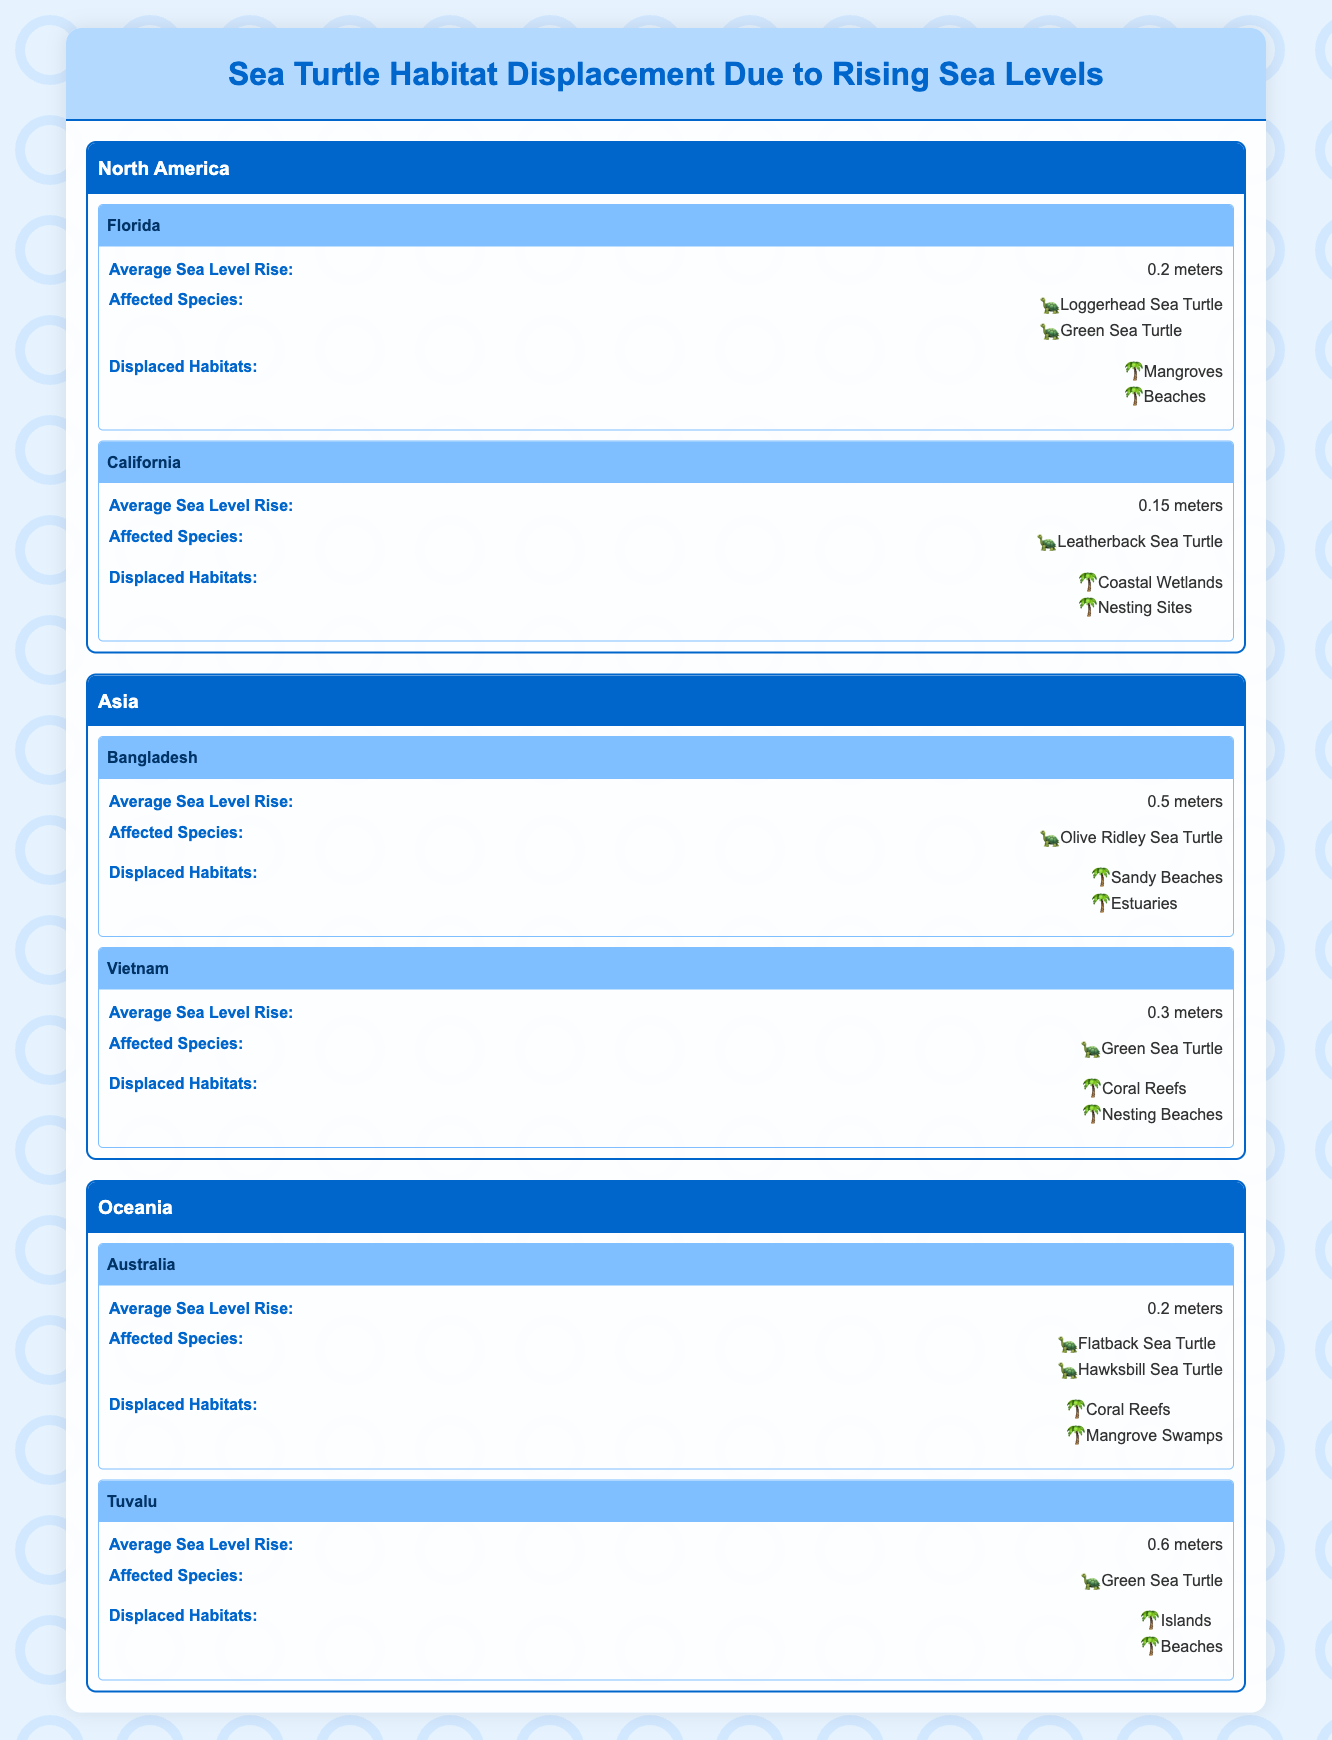What is the average sea level rise in Florida? In the table, the average sea level rise for Florida is listed directly under the state. It states that the average sea level rise is 0.2 meters.
Answer: 0.2 meters Which species are affected in Bangladesh? The table provides specific information about affected species under Bangladesh. The affected species are listed as "Olive Ridley Sea Turtle."
Answer: Olive Ridley Sea Turtle Is the average sea level rise in Vietnam greater than that in California? The average sea level rise for Vietnam is 0.3 meters, while for California, it is 0.15 meters. Since 0.3 is greater than 0.15, the statement is true.
Answer: Yes How many types of displaced habitats are identified in Tuvalu? Tuvalu has two displaced habitats listed in the table: "Islands" and "Beaches." Therefore, there are two types of displaced habitats.
Answer: 2 Which region has the highest average sea level rise, and how much is it? Upon examining the average sea level rise values, Bangladesh has the highest at 0.5 meters. The comparison reveals that 0.5 meters (Bangladesh) is higher than all other listed regions.
Answer: Bangladesh, 0.5 meters Do any states in North America have the same average sea level rise? In the table, both Florida and Australia have an average sea level rise of 0.2 meters, indicating they have the same average. The focus is specifically on North America, which includes Florida and California. Since Florida (0.2 meters) and California (0.15 meters) are both fewer than the two states, the statement is false.
Answer: No What is the total number of affected species identified for Australia? In Australia, the table lists two affected species: "Flatback Sea Turtle" and "Hawksbill Sea Turtle." Adding these up gives a total of two affected species.
Answer: 2 Which region has the most diverse habitats? To determine habitat diversity, we look at the number of displaced habitats. North America (Florida) has two habitats; Asia (Vietnam) has two; Oceania (Australia) has two. However, if we consider Tuvalu, it also has two. Thus, we summarize that regions listed either all have two habitats. Since they are the same in counts, the statement could indicate all have equal diversity.
Answer: All regions have equal diversity 